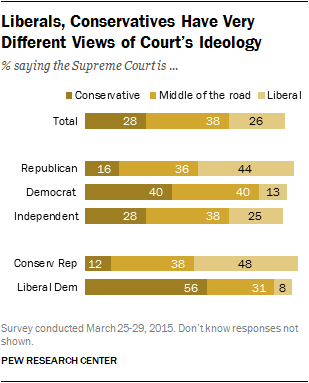Give some essential details in this illustration. The brown bar represents the value of being conservative. The difference between the maximum value of a conservative and the minimum value of a liberal is 48. 